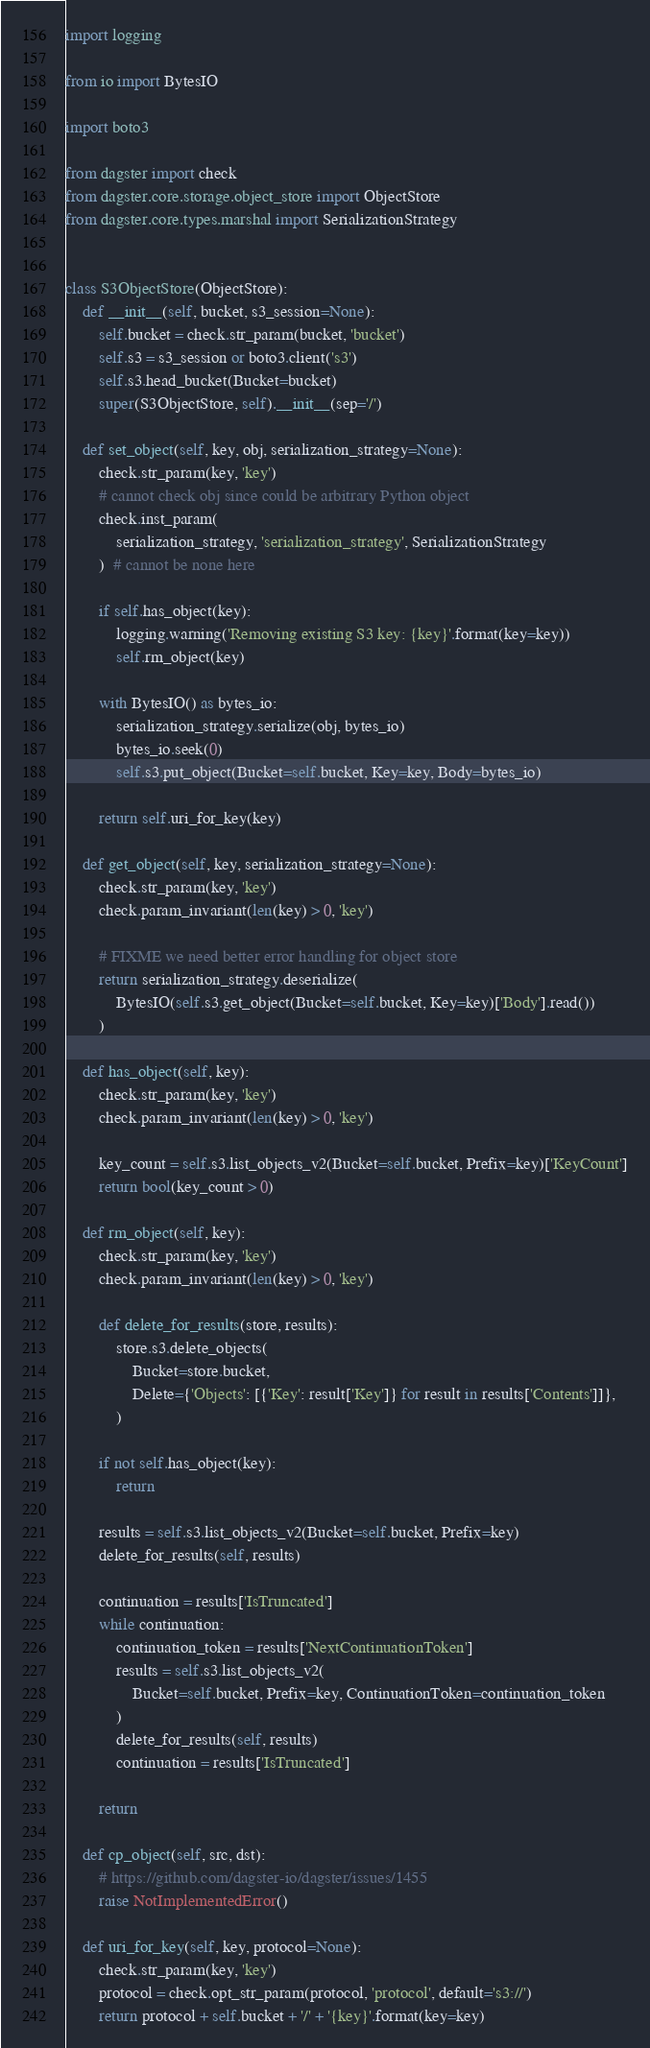Convert code to text. <code><loc_0><loc_0><loc_500><loc_500><_Python_>import logging

from io import BytesIO

import boto3

from dagster import check
from dagster.core.storage.object_store import ObjectStore
from dagster.core.types.marshal import SerializationStrategy


class S3ObjectStore(ObjectStore):
    def __init__(self, bucket, s3_session=None):
        self.bucket = check.str_param(bucket, 'bucket')
        self.s3 = s3_session or boto3.client('s3')
        self.s3.head_bucket(Bucket=bucket)
        super(S3ObjectStore, self).__init__(sep='/')

    def set_object(self, key, obj, serialization_strategy=None):
        check.str_param(key, 'key')
        # cannot check obj since could be arbitrary Python object
        check.inst_param(
            serialization_strategy, 'serialization_strategy', SerializationStrategy
        )  # cannot be none here

        if self.has_object(key):
            logging.warning('Removing existing S3 key: {key}'.format(key=key))
            self.rm_object(key)

        with BytesIO() as bytes_io:
            serialization_strategy.serialize(obj, bytes_io)
            bytes_io.seek(0)
            self.s3.put_object(Bucket=self.bucket, Key=key, Body=bytes_io)

        return self.uri_for_key(key)

    def get_object(self, key, serialization_strategy=None):
        check.str_param(key, 'key')
        check.param_invariant(len(key) > 0, 'key')

        # FIXME we need better error handling for object store
        return serialization_strategy.deserialize(
            BytesIO(self.s3.get_object(Bucket=self.bucket, Key=key)['Body'].read())
        )

    def has_object(self, key):
        check.str_param(key, 'key')
        check.param_invariant(len(key) > 0, 'key')

        key_count = self.s3.list_objects_v2(Bucket=self.bucket, Prefix=key)['KeyCount']
        return bool(key_count > 0)

    def rm_object(self, key):
        check.str_param(key, 'key')
        check.param_invariant(len(key) > 0, 'key')

        def delete_for_results(store, results):
            store.s3.delete_objects(
                Bucket=store.bucket,
                Delete={'Objects': [{'Key': result['Key']} for result in results['Contents']]},
            )

        if not self.has_object(key):
            return

        results = self.s3.list_objects_v2(Bucket=self.bucket, Prefix=key)
        delete_for_results(self, results)

        continuation = results['IsTruncated']
        while continuation:
            continuation_token = results['NextContinuationToken']
            results = self.s3.list_objects_v2(
                Bucket=self.bucket, Prefix=key, ContinuationToken=continuation_token
            )
            delete_for_results(self, results)
            continuation = results['IsTruncated']

        return

    def cp_object(self, src, dst):
        # https://github.com/dagster-io/dagster/issues/1455
        raise NotImplementedError()

    def uri_for_key(self, key, protocol=None):
        check.str_param(key, 'key')
        protocol = check.opt_str_param(protocol, 'protocol', default='s3://')
        return protocol + self.bucket + '/' + '{key}'.format(key=key)
</code> 